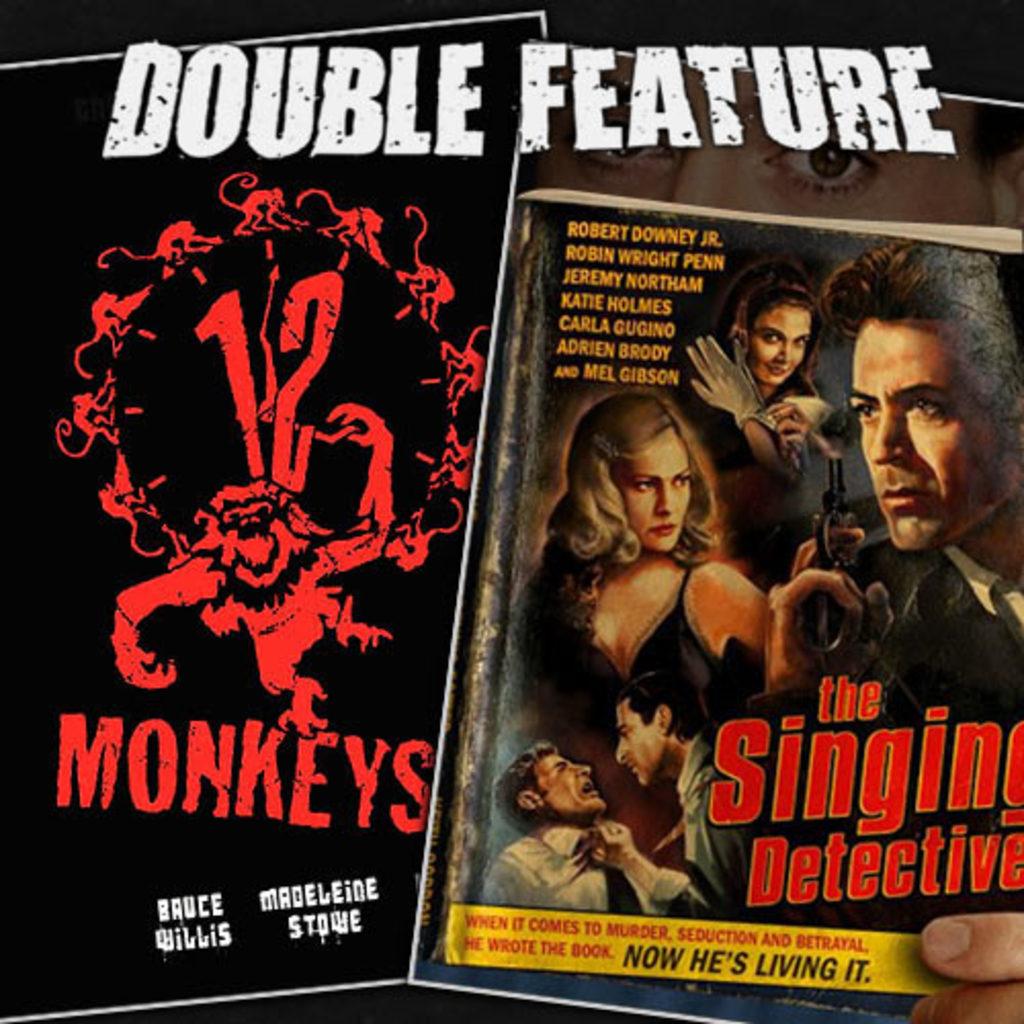What actor is in 12 monkeys?
Ensure brevity in your answer.  Bruce willis. What is the title of the movie on the left?
Provide a succinct answer. 12 monkeys. 